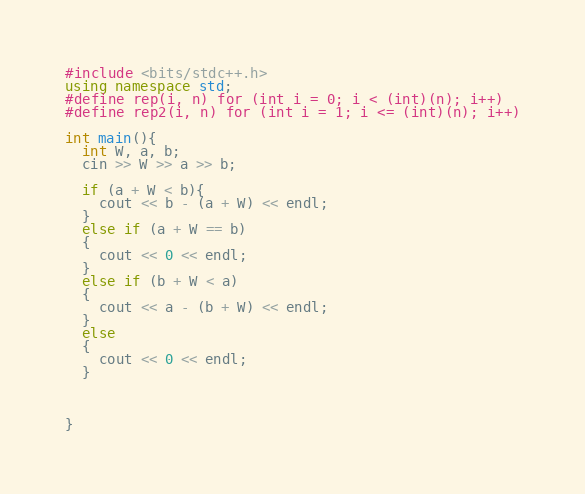Convert code to text. <code><loc_0><loc_0><loc_500><loc_500><_C++_>#include <bits/stdc++.h>
using namespace std;
#define rep(i, n) for (int i = 0; i < (int)(n); i++)
#define rep2(i, n) for (int i = 1; i <= (int)(n); i++)

int main(){
  int W, a, b;
  cin >> W >> a >> b;

  if (a + W < b){
    cout << b - (a + W) << endl;
  }
  else if (a + W == b)
  {
    cout << 0 << endl;
  }
  else if (b + W < a)
  {
    cout << a - (b + W) << endl;
  }
  else
  {
    cout << 0 << endl;
  }
  
  
  
}</code> 